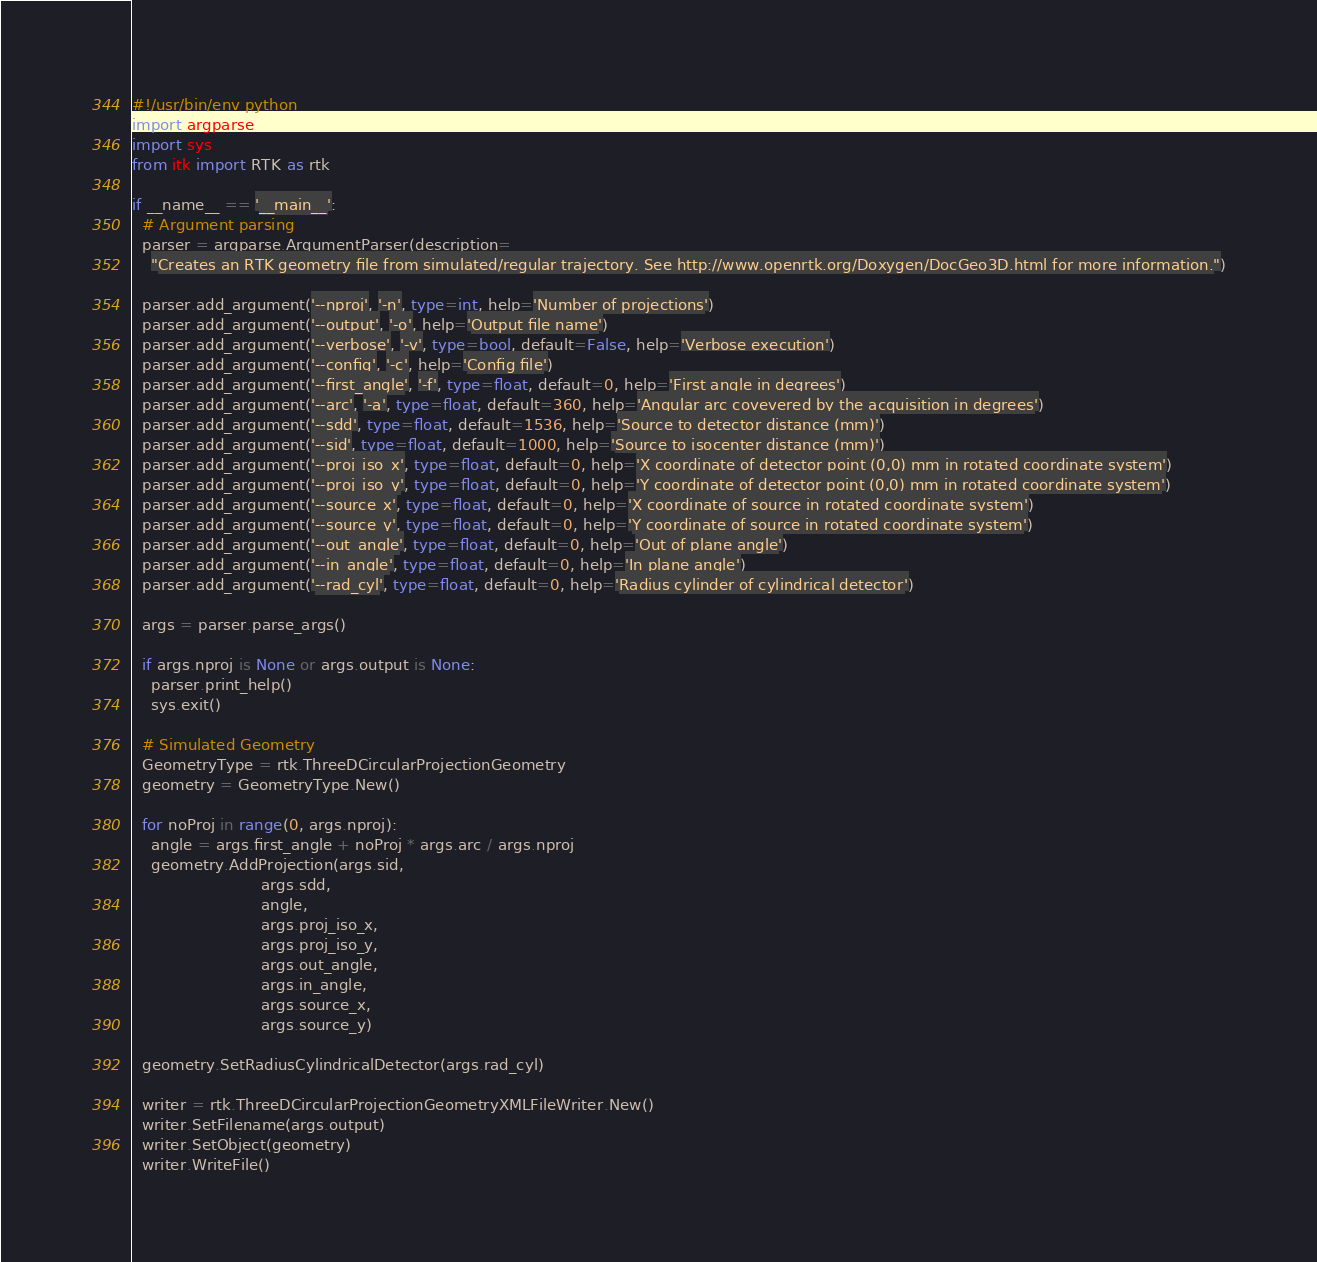Convert code to text. <code><loc_0><loc_0><loc_500><loc_500><_Python_>#!/usr/bin/env python
import argparse
import sys
from itk import RTK as rtk

if __name__ == '__main__':
  # Argument parsing
  parser = argparse.ArgumentParser(description=
    "Creates an RTK geometry file from simulated/regular trajectory. See http://www.openrtk.org/Doxygen/DocGeo3D.html for more information.")

  parser.add_argument('--nproj', '-n', type=int, help='Number of projections')
  parser.add_argument('--output', '-o', help='Output file name')
  parser.add_argument('--verbose', '-v', type=bool, default=False, help='Verbose execution')
  parser.add_argument('--config', '-c', help='Config file')
  parser.add_argument('--first_angle', '-f', type=float, default=0, help='First angle in degrees')
  parser.add_argument('--arc', '-a', type=float, default=360, help='Angular arc covevered by the acquisition in degrees')
  parser.add_argument('--sdd', type=float, default=1536, help='Source to detector distance (mm)')
  parser.add_argument('--sid', type=float, default=1000, help='Source to isocenter distance (mm)')
  parser.add_argument('--proj_iso_x', type=float, default=0, help='X coordinate of detector point (0,0) mm in rotated coordinate system')
  parser.add_argument('--proj_iso_y', type=float, default=0, help='Y coordinate of detector point (0,0) mm in rotated coordinate system')
  parser.add_argument('--source_x', type=float, default=0, help='X coordinate of source in rotated coordinate system')
  parser.add_argument('--source_y', type=float, default=0, help='Y coordinate of source in rotated coordinate system')
  parser.add_argument('--out_angle', type=float, default=0, help='Out of plane angle')
  parser.add_argument('--in_angle', type=float, default=0, help='In plane angle')
  parser.add_argument('--rad_cyl', type=float, default=0, help='Radius cylinder of cylindrical detector')

  args = parser.parse_args()

  if args.nproj is None or args.output is None:
    parser.print_help()
    sys.exit()

  # Simulated Geometry
  GeometryType = rtk.ThreeDCircularProjectionGeometry
  geometry = GeometryType.New()

  for noProj in range(0, args.nproj):
    angle = args.first_angle + noProj * args.arc / args.nproj
    geometry.AddProjection(args.sid,
                           args.sdd,
                           angle,
                           args.proj_iso_x,
                           args.proj_iso_y,
                           args.out_angle,
                           args.in_angle,
                           args.source_x,
                           args.source_y)

  geometry.SetRadiusCylindricalDetector(args.rad_cyl)

  writer = rtk.ThreeDCircularProjectionGeometryXMLFileWriter.New()
  writer.SetFilename(args.output)
  writer.SetObject(geometry)
  writer.WriteFile()
</code> 